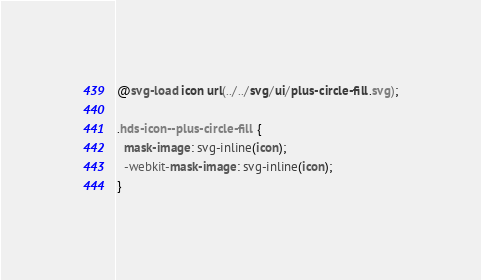Convert code to text. <code><loc_0><loc_0><loc_500><loc_500><_CSS_>@svg-load icon url(../../svg/ui/plus-circle-fill.svg);

.hds-icon--plus-circle-fill {
  mask-image: svg-inline(icon);
  -webkit-mask-image: svg-inline(icon);
}
</code> 